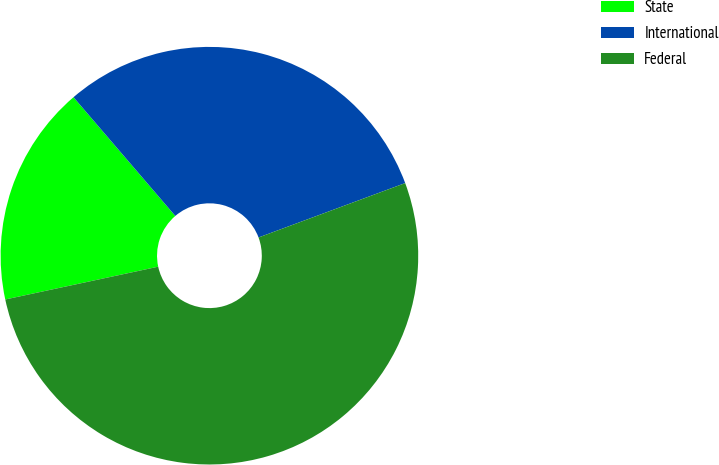Convert chart. <chart><loc_0><loc_0><loc_500><loc_500><pie_chart><fcel>State<fcel>International<fcel>Federal<nl><fcel>17.08%<fcel>30.63%<fcel>52.29%<nl></chart> 